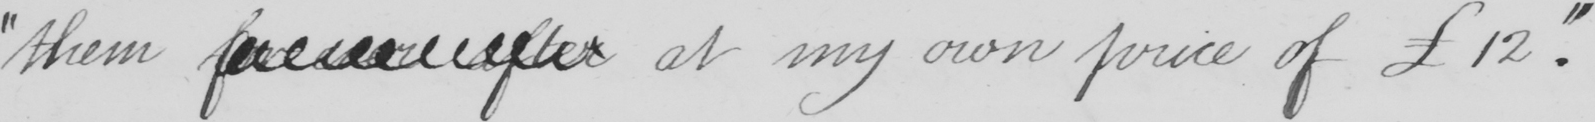What text is written in this handwritten line? " them forever after at my own price of 12 . " 